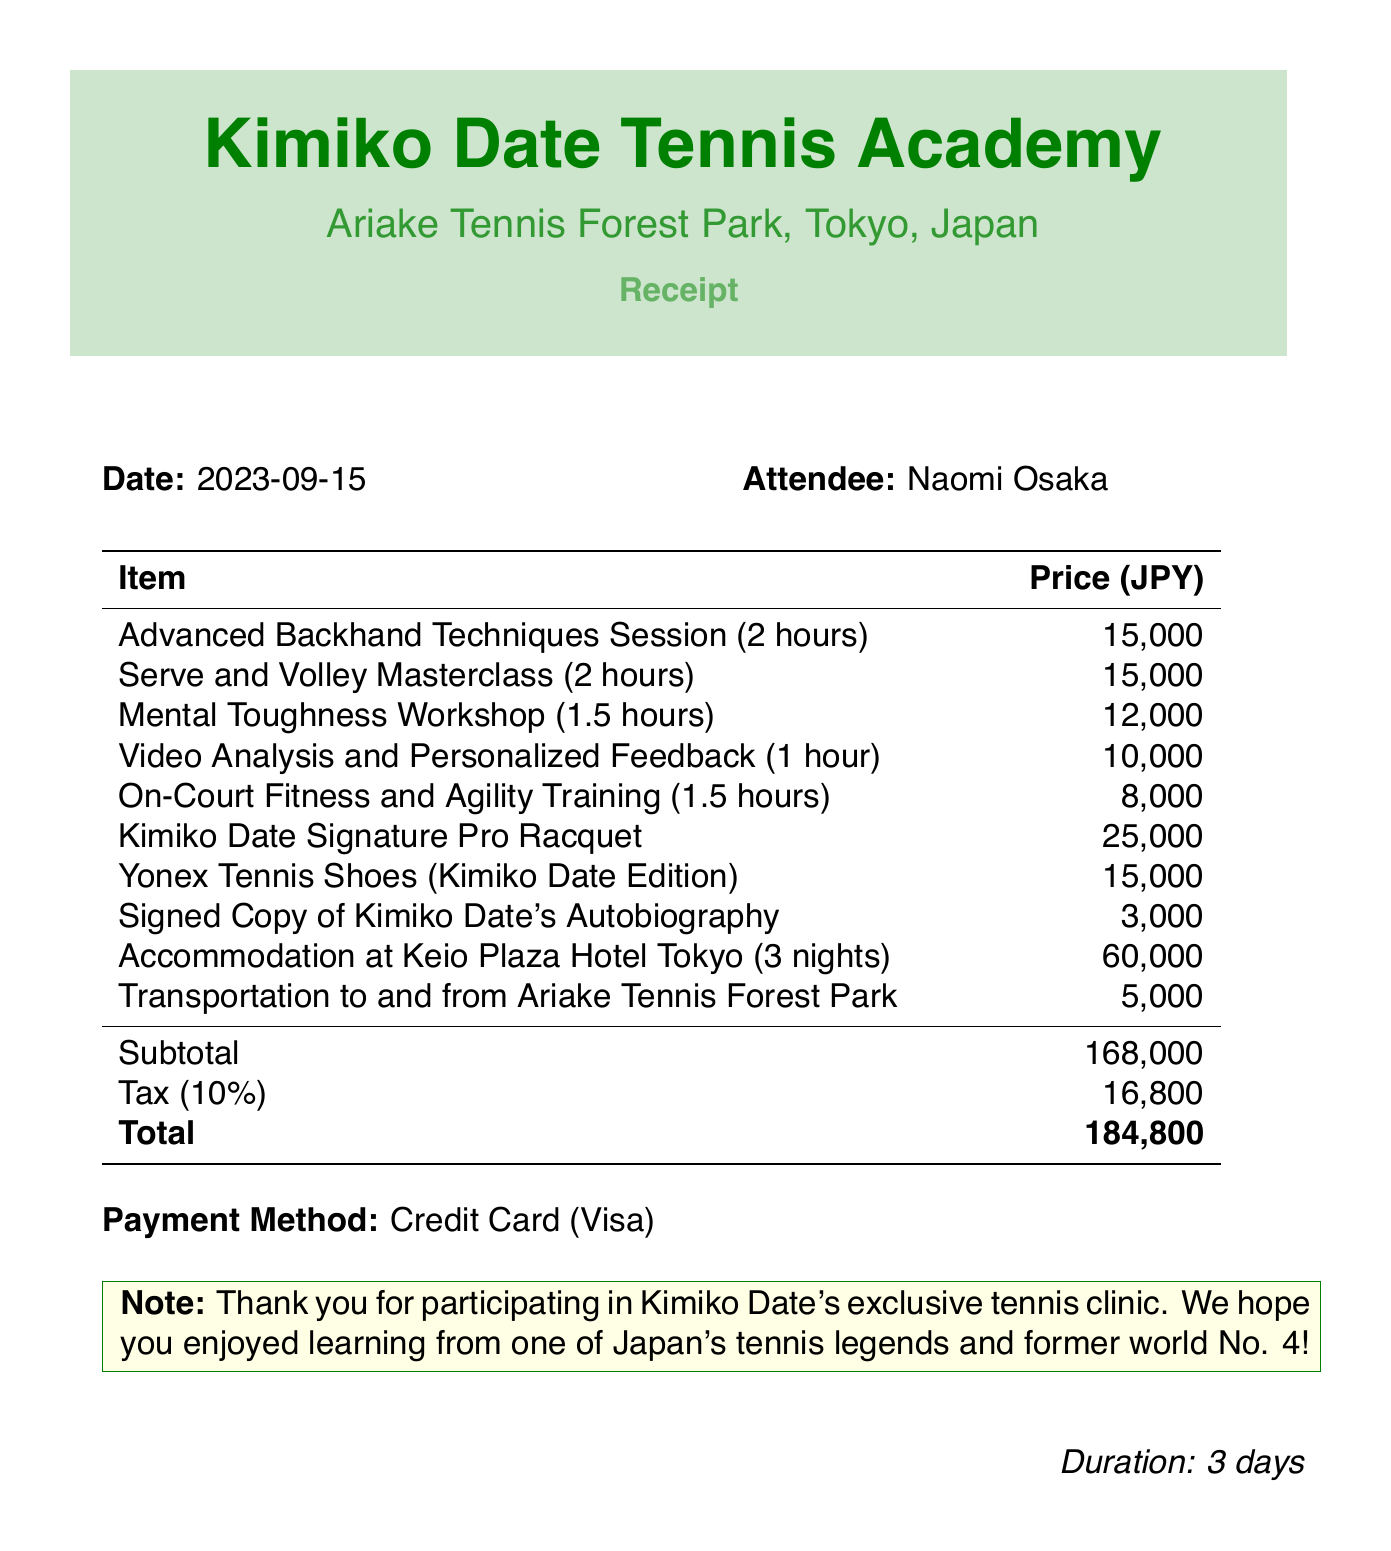What is the clinic name? The clinic name is the title at the top of the receipt, indicating where the services were provided.
Answer: Kimiko Date Tennis Academy Who was the instructor for the Advanced Backhand Techniques Session? The instructor's name is listed alongside each session in the itemized section of the document.
Answer: Kimiko Date What is the total amount charged? The total is found at the bottom of the itemized table and includes all items and tax.
Answer: 184,800 How many nights was accommodation provided? The number of nights for accommodation can be inferred from the description of the accommodation item.
Answer: 3 nights What type of shoes were included in the package? The type of shoes is specified in the description of one of the items in the list.
Answer: Yonex Tennis Shoes (Kimiko Date Edition) What is the price of the Mental Toughness Workshop? The price is stated next to the description of the workshop in the itemized section.
Answer: 12,000 What payment method was used? The payment method is indicated in a dedicated section towards the end of the document.
Answer: Credit Card (Visa) What location hosted the clinic? The location is mentioned under the clinic name and provides context for where the event took place.
Answer: Ariake Tennis Forest Park, Tokyo, Japan What is the duration of the tennis clinic package? The duration is stated in a separate line towards the end of the document, summarizing the clinic length.
Answer: 3 days 